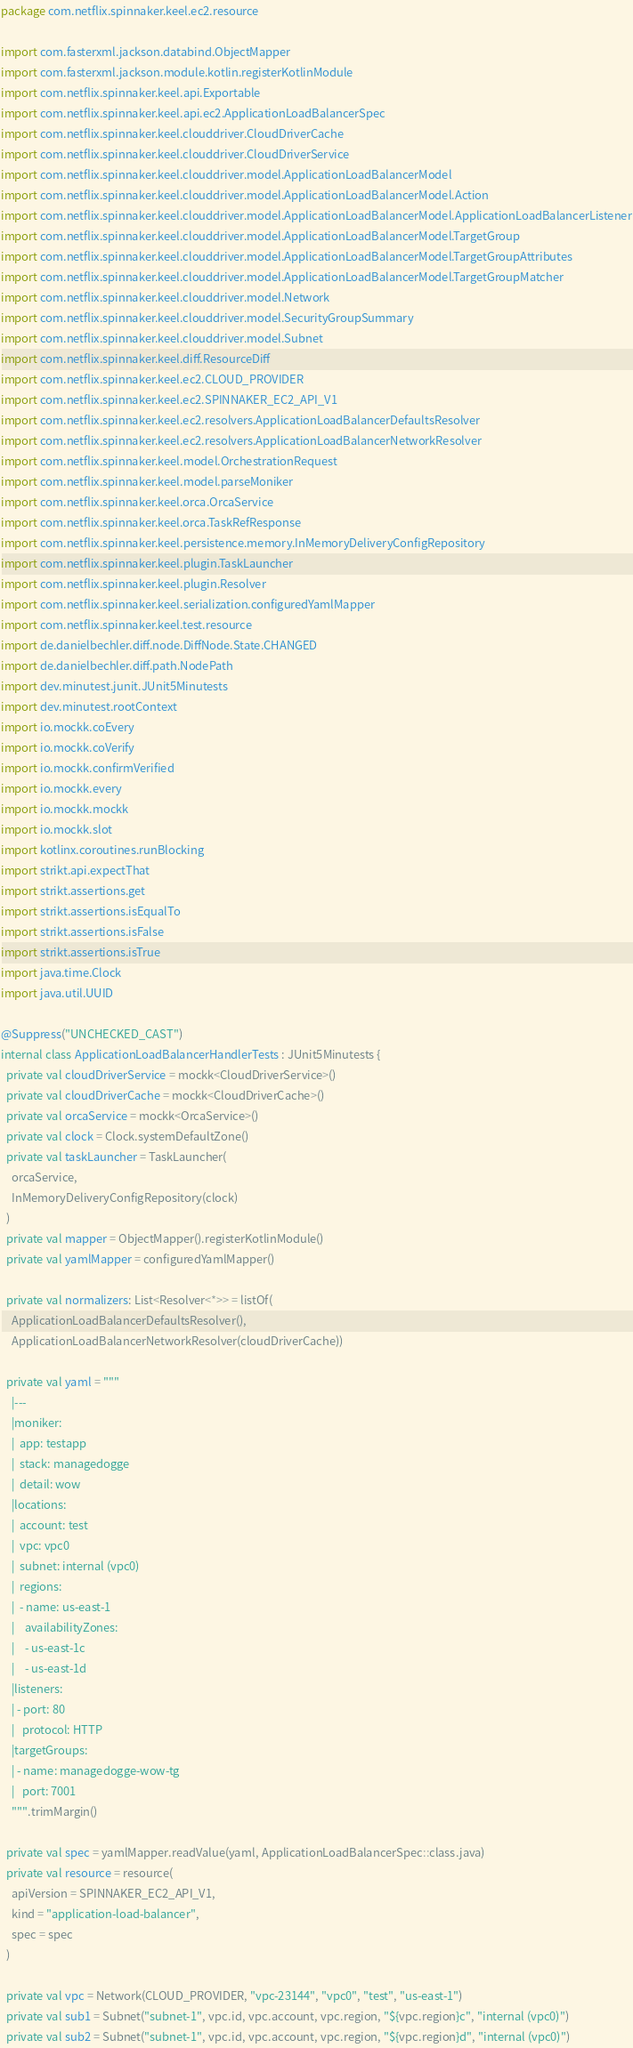Convert code to text. <code><loc_0><loc_0><loc_500><loc_500><_Kotlin_>package com.netflix.spinnaker.keel.ec2.resource

import com.fasterxml.jackson.databind.ObjectMapper
import com.fasterxml.jackson.module.kotlin.registerKotlinModule
import com.netflix.spinnaker.keel.api.Exportable
import com.netflix.spinnaker.keel.api.ec2.ApplicationLoadBalancerSpec
import com.netflix.spinnaker.keel.clouddriver.CloudDriverCache
import com.netflix.spinnaker.keel.clouddriver.CloudDriverService
import com.netflix.spinnaker.keel.clouddriver.model.ApplicationLoadBalancerModel
import com.netflix.spinnaker.keel.clouddriver.model.ApplicationLoadBalancerModel.Action
import com.netflix.spinnaker.keel.clouddriver.model.ApplicationLoadBalancerModel.ApplicationLoadBalancerListener
import com.netflix.spinnaker.keel.clouddriver.model.ApplicationLoadBalancerModel.TargetGroup
import com.netflix.spinnaker.keel.clouddriver.model.ApplicationLoadBalancerModel.TargetGroupAttributes
import com.netflix.spinnaker.keel.clouddriver.model.ApplicationLoadBalancerModel.TargetGroupMatcher
import com.netflix.spinnaker.keel.clouddriver.model.Network
import com.netflix.spinnaker.keel.clouddriver.model.SecurityGroupSummary
import com.netflix.spinnaker.keel.clouddriver.model.Subnet
import com.netflix.spinnaker.keel.diff.ResourceDiff
import com.netflix.spinnaker.keel.ec2.CLOUD_PROVIDER
import com.netflix.spinnaker.keel.ec2.SPINNAKER_EC2_API_V1
import com.netflix.spinnaker.keel.ec2.resolvers.ApplicationLoadBalancerDefaultsResolver
import com.netflix.spinnaker.keel.ec2.resolvers.ApplicationLoadBalancerNetworkResolver
import com.netflix.spinnaker.keel.model.OrchestrationRequest
import com.netflix.spinnaker.keel.model.parseMoniker
import com.netflix.spinnaker.keel.orca.OrcaService
import com.netflix.spinnaker.keel.orca.TaskRefResponse
import com.netflix.spinnaker.keel.persistence.memory.InMemoryDeliveryConfigRepository
import com.netflix.spinnaker.keel.plugin.TaskLauncher
import com.netflix.spinnaker.keel.plugin.Resolver
import com.netflix.spinnaker.keel.serialization.configuredYamlMapper
import com.netflix.spinnaker.keel.test.resource
import de.danielbechler.diff.node.DiffNode.State.CHANGED
import de.danielbechler.diff.path.NodePath
import dev.minutest.junit.JUnit5Minutests
import dev.minutest.rootContext
import io.mockk.coEvery
import io.mockk.coVerify
import io.mockk.confirmVerified
import io.mockk.every
import io.mockk.mockk
import io.mockk.slot
import kotlinx.coroutines.runBlocking
import strikt.api.expectThat
import strikt.assertions.get
import strikt.assertions.isEqualTo
import strikt.assertions.isFalse
import strikt.assertions.isTrue
import java.time.Clock
import java.util.UUID

@Suppress("UNCHECKED_CAST")
internal class ApplicationLoadBalancerHandlerTests : JUnit5Minutests {
  private val cloudDriverService = mockk<CloudDriverService>()
  private val cloudDriverCache = mockk<CloudDriverCache>()
  private val orcaService = mockk<OrcaService>()
  private val clock = Clock.systemDefaultZone()
  private val taskLauncher = TaskLauncher(
    orcaService,
    InMemoryDeliveryConfigRepository(clock)
  )
  private val mapper = ObjectMapper().registerKotlinModule()
  private val yamlMapper = configuredYamlMapper()

  private val normalizers: List<Resolver<*>> = listOf(
    ApplicationLoadBalancerDefaultsResolver(),
    ApplicationLoadBalancerNetworkResolver(cloudDriverCache))

  private val yaml = """
    |---
    |moniker:
    |  app: testapp
    |  stack: managedogge
    |  detail: wow
    |locations:
    |  account: test
    |  vpc: vpc0
    |  subnet: internal (vpc0)
    |  regions:
    |  - name: us-east-1
    |    availabilityZones:
    |    - us-east-1c
    |    - us-east-1d
    |listeners:
    | - port: 80
    |   protocol: HTTP
    |targetGroups:
    | - name: managedogge-wow-tg
    |   port: 7001
    """.trimMargin()

  private val spec = yamlMapper.readValue(yaml, ApplicationLoadBalancerSpec::class.java)
  private val resource = resource(
    apiVersion = SPINNAKER_EC2_API_V1,
    kind = "application-load-balancer",
    spec = spec
  )

  private val vpc = Network(CLOUD_PROVIDER, "vpc-23144", "vpc0", "test", "us-east-1")
  private val sub1 = Subnet("subnet-1", vpc.id, vpc.account, vpc.region, "${vpc.region}c", "internal (vpc0)")
  private val sub2 = Subnet("subnet-1", vpc.id, vpc.account, vpc.region, "${vpc.region}d", "internal (vpc0)")</code> 